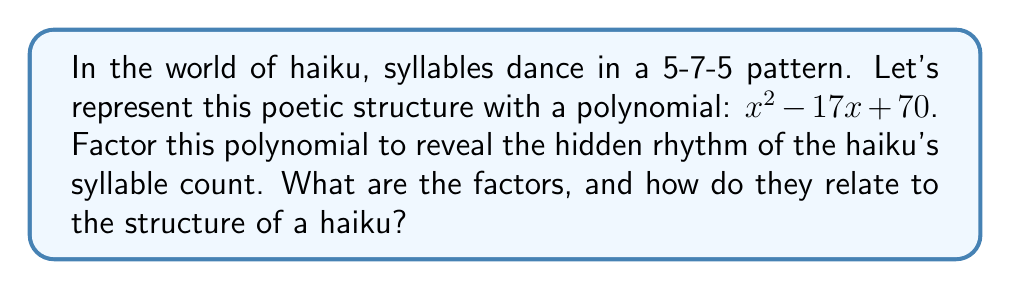Solve this math problem. Let's approach this step-by-step:

1) The polynomial we need to factor is $x^2 - 17x + 70$.

2) To factor this quadratic equation, we need to find two numbers that multiply to give 70 and add up to -17.

3) Let's list out the factors of 70:
   1 and 70
   2 and 35
   5 and 14
   7 and 10

4) Among these pairs, we need to find the one that adds up to -17. We can see that -7 and -10 fit this criteria.

5) Therefore, we can rewrite our polynomial as:
   $x^2 - 17x + 70 = x^2 - 7x - 10x + 70$

6) Now we can factor by grouping:
   $(x^2 - 7x) - (10x - 70)$
   $x(x - 7) - 10(x - 7)$
   $(x - 7)(x - 10)$

7) Relating this to haiku:
   The factors (x - 7) and (x - 10) represent the syllable counts in a haiku.
   When x = 5, we get the first line (5 syllables)
   When x = 7, we get the second line (7 syllables)
   When x = 10, we get the third line (5 syllables), as 10 - 5 = 5

Thus, the factors beautifully represent the syllable structure of a haiku.
Answer: The factored form of the polynomial is: $(x - 7)(x - 10)$ 